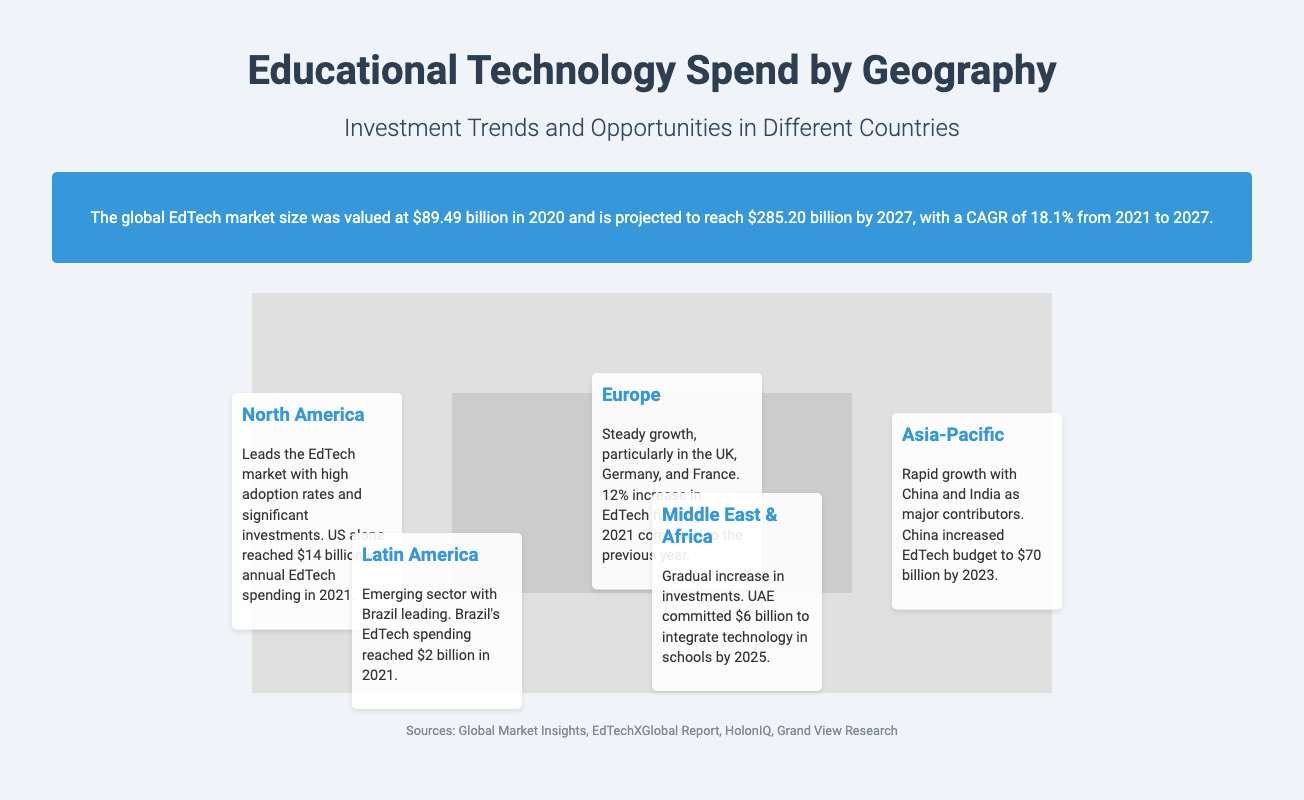what was the global EdTech market size in 2020? The document states that the global EdTech market size was valued at $89.49 billion in 2020.
Answer: $89.49 billion what is the projected market size by 2027? According to the document, the projected market size for 2027 is $285.20 billion.
Answer: $285.20 billion which region leads in EdTech spending? The document indicates that North America leads the EdTech market with high adoption rates and significant investments.
Answer: North America how much did the US spend on EdTech in 2021? The document mentions that the US alone reached $14 billion in annual EdTech spending in 2021.
Answer: $14 billion what was the percentage increase of EdTech funding in Europe in 2021? The document states that there was a 12% increase in EdTech funding in Europe in 2021 compared to the previous year.
Answer: 12% which two countries are major contributors to the Asia-Pacific EdTech market? The document refers to China and India as major contributors to the rapid growth in the Asia-Pacific region.
Answer: China and India how much did Brazil spend on EdTech in 2021? Brazil's EdTech spending reached $2 billion in 2021, as mentioned in the document.
Answer: $2 billion what is the investment commitment of the UAE toward EdTech by 2025? The document shows that the UAE committed $6 billion to integrate technology in schools by 2025.
Answer: $6 billion what trend is observed in the EdTech market across different countries? The document illustrates a trend of increasing investments and growth opportunities in various regions worldwide.
Answer: Increasing investments 